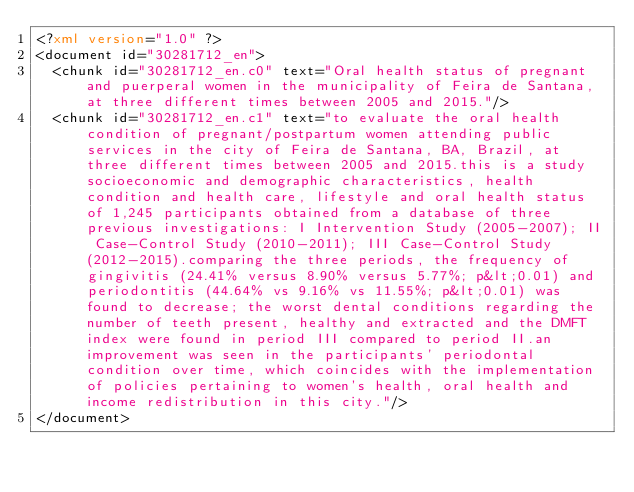<code> <loc_0><loc_0><loc_500><loc_500><_XML_><?xml version="1.0" ?>
<document id="30281712_en">
  <chunk id="30281712_en.c0" text="Oral health status of pregnant and puerperal women in the municipality of Feira de Santana, at three different times between 2005 and 2015."/>
  <chunk id="30281712_en.c1" text="to evaluate the oral health condition of pregnant/postpartum women attending public services in the city of Feira de Santana, BA, Brazil, at three different times between 2005 and 2015.this is a study socioeconomic and demographic characteristics, health condition and health care, lifestyle and oral health status of 1,245 participants obtained from a database of three previous investigations: I Intervention Study (2005-2007); II Case-Control Study (2010-2011); III Case-Control Study (2012-2015).comparing the three periods, the frequency of gingivitis (24.41% versus 8.90% versus 5.77%; p&lt;0.01) and periodontitis (44.64% vs 9.16% vs 11.55%; p&lt;0.01) was found to decrease; the worst dental conditions regarding the number of teeth present, healthy and extracted and the DMFT index were found in period III compared to period II.an improvement was seen in the participants' periodontal condition over time, which coincides with the implementation of policies pertaining to women's health, oral health and income redistribution in this city."/>
</document>
</code> 